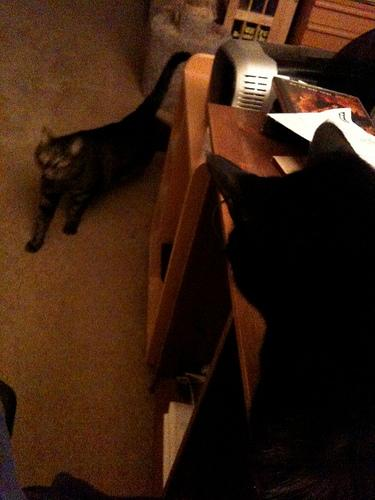From the information given, analyze the general context and mood of the image. The image depicts a typical domestic scene in which two cats interact within a space furnished with wooden office furniture, documents, and light brown carpeting. Distinguish the main objects in the image and state their respective sizes (width and height). Brown wooden office furniture (Width:221 Height:221), two cats (black cat Width:161 Height:161; grey and black cat Width:139 Height:139), and light brown carpet (Width:149 Height:149). Characterize the types of flooring and furniture materials in the image. The floor has a tan carpet and a dark gold carpet, while the furniture includes brown wooden office furniture, a smaller wooden table, and a wooden storage unit. Provide a one-sentence summary of the image focusing on the most prominent objects and their interactions. Two cats, one black and the other grey and black, are in a house with brown wooden office furniture, a small wooden table, documents inside a desk shelf, and a light brown carpet on the tan floor. List down various objects found on and within the surrounding furniture items in the image. DVD cover, letter, CD, documents inside desk shelf, white papers in cabinet, stack of papers on shelf, and a white envelope on the table. Detect any anomalies in the image regarding the cats and their environment. No apparent anomalies are detected within the cats and their environment – it seems to be a normal household setting. Considering the cats' activities and the image's overall setting, infer a possible sentiment or emotion that the image might evoke. The image might evoke a sense of warmth and coziness, as the cats appear calm and curious amidst a comfortable home setting. Is there a green plant on the smaller table? No, it's not mentioned in the image. Is the brown cat sitting on top of the wooden desk? None of the cats are described as brown; there are only black, grey, and tan cats in the image. Is the cat sitting on the blue carpet in the room? There is no blue carpet in the room; the carpet is described as light brown, tan, and dark gold. 